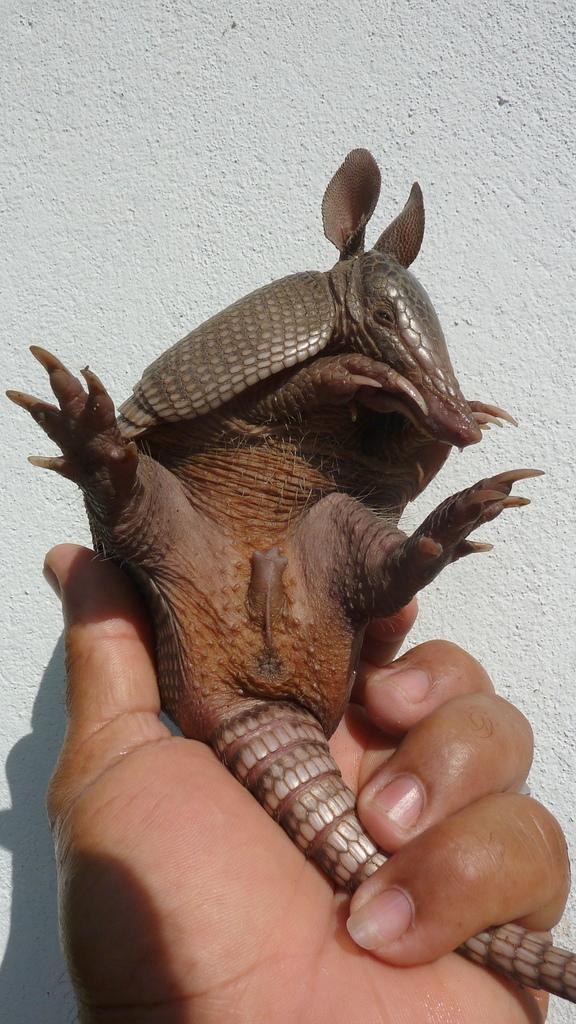In one or two sentences, can you explain what this image depicts? To the bottom of the image there is a person hand holding an armadillo in their hand. And in the background there is a wall. 